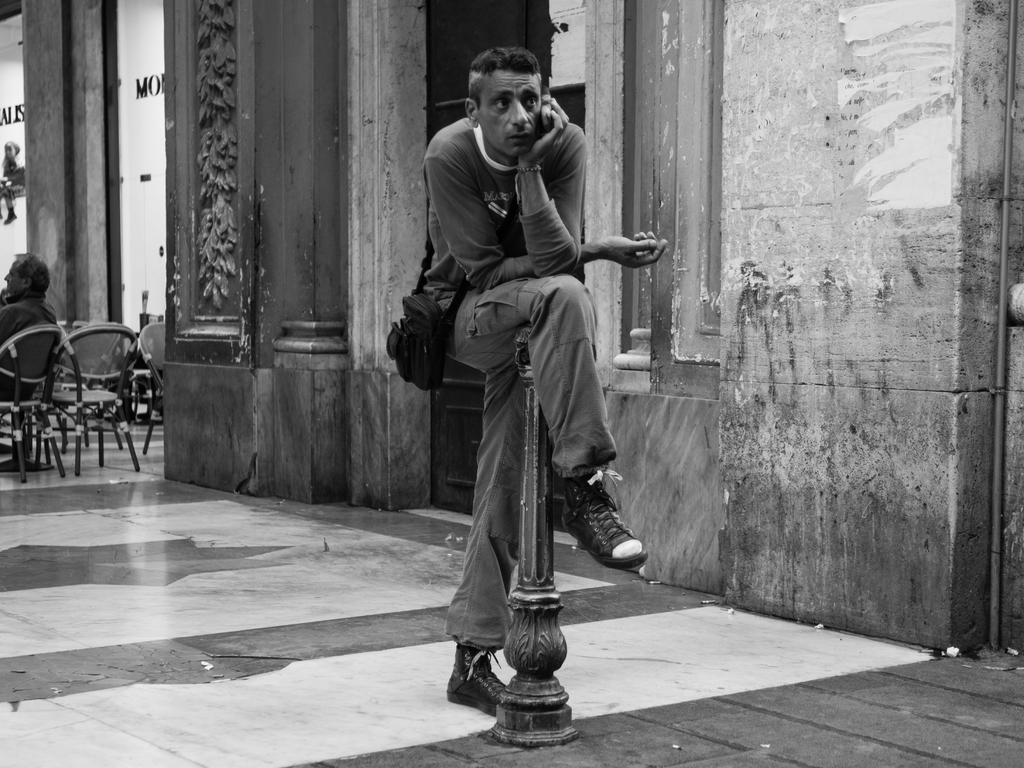How would you summarize this image in a sentence or two? This is the black and white image and we can see a person holding an object and there is an object which looks like a pole on the floor and we can see some chairs. There is a person sitting on a chair on the left side of the image and we can see a building. 